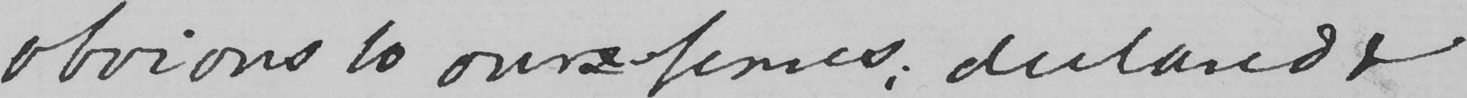What does this handwritten line say? obvious to ourselves , declared & 